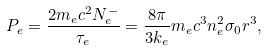Convert formula to latex. <formula><loc_0><loc_0><loc_500><loc_500>P _ { e } = \frac { 2 m _ { e } c ^ { 2 } N _ { e } ^ { - } } { \tau _ { e } } = \frac { 8 \pi } { 3 k _ { e } } m _ { e } c ^ { 3 } n _ { e } ^ { 2 } \sigma _ { 0 } r ^ { 3 } ,</formula> 